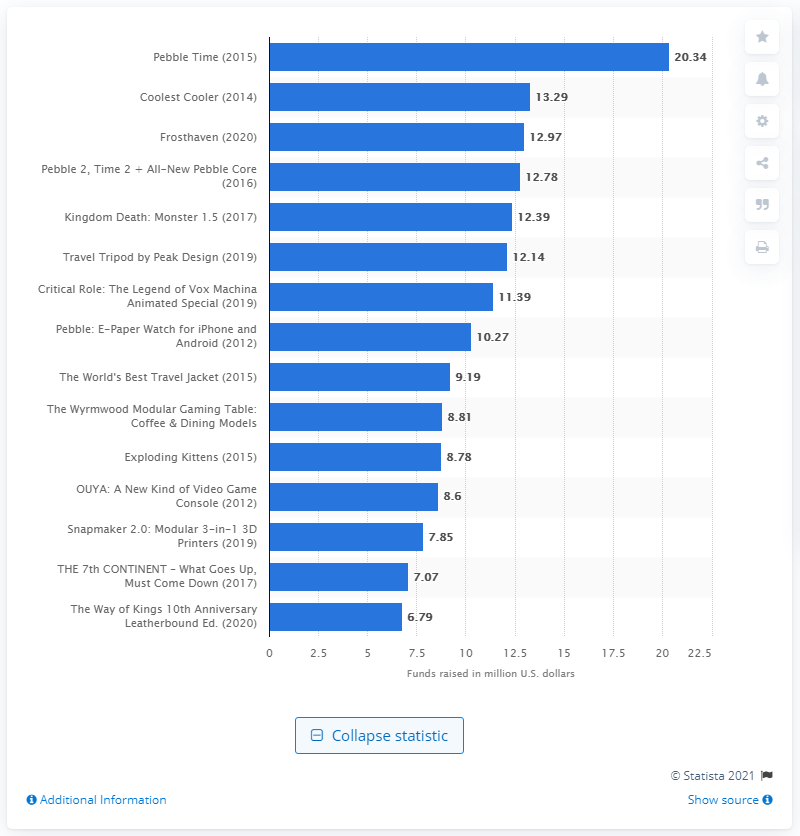Highlight a few significant elements in this photo. The Pebble e-paper watch raised a total of $10,279,849 on Kickstarter. The Coolest Cooler raised a total of $13.29 in August 2014. 